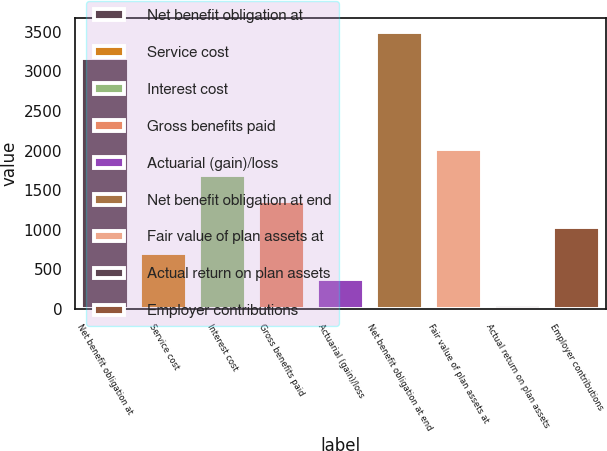<chart> <loc_0><loc_0><loc_500><loc_500><bar_chart><fcel>Net benefit obligation at<fcel>Service cost<fcel>Interest cost<fcel>Gross benefits paid<fcel>Actuarial (gain)/loss<fcel>Net benefit obligation at end<fcel>Fair value of plan assets at<fcel>Actual return on plan assets<fcel>Employer contributions<nl><fcel>3166<fcel>702.4<fcel>1690<fcel>1360.8<fcel>373.2<fcel>3495.2<fcel>2019.2<fcel>44<fcel>1031.6<nl></chart> 